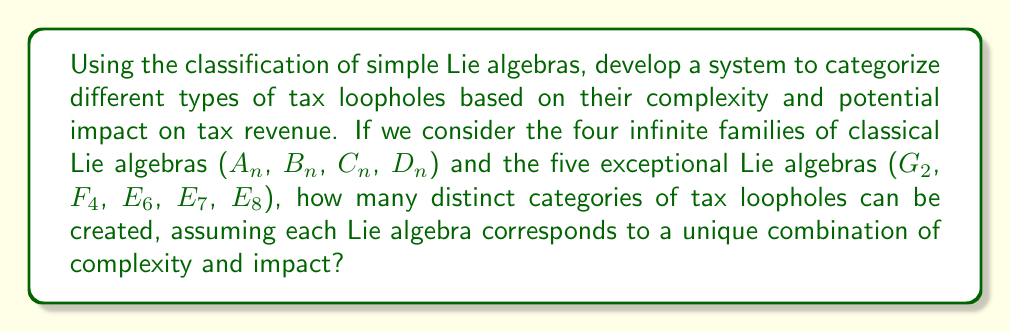Teach me how to tackle this problem. To solve this problem, we need to understand the classification of simple Lie algebras and apply it to our tax loophole categorization system:

1. The classical Lie algebras consist of four infinite families:
   - $A_n$ (for $n \geq 1$)
   - $B_n$ (for $n \geq 2$)
   - $C_n$ (for $n \geq 3$)
   - $D_n$ (for $n \geq 4$)

2. The exceptional Lie algebras are:
   - $G_2$
   - $F_4$
   - $E_6$
   - $E_7$
   - $E_8$

3. Each Lie algebra can represent a unique combination of complexity and impact for tax loopholes. For example:
   - $A_n$ could represent loopholes with increasing complexity as $n$ increases
   - $B_n$, $C_n$, and $D_n$ could represent different types of structural loopholes
   - The exceptional algebras could represent rare, high-impact loopholes

4. To count the distinct categories, we need to consider:
   - The lowest rank for each classical family that doesn't overlap with others
   - All exceptional algebras

5. Counting the distinct categories:
   - $A_1$, $A_2$, $A_3$, $A_n$ (for $n \geq 4$): 4 categories
   - $B_2$, $B_n$ (for $n \geq 3$): 2 categories
   - $C_3$, $C_n$ (for $n \geq 4$): 2 categories
   - $D_4$, $D_n$ (for $n \geq 5$): 2 categories
   - $G_2$, $F_4$, $E_6$, $E_7$, $E_8$: 5 categories

6. Total number of distinct categories: 4 + 2 + 2 + 2 + 5 = 15
Answer: 15 distinct categories of tax loopholes can be created based on the classification of simple Lie algebras. 